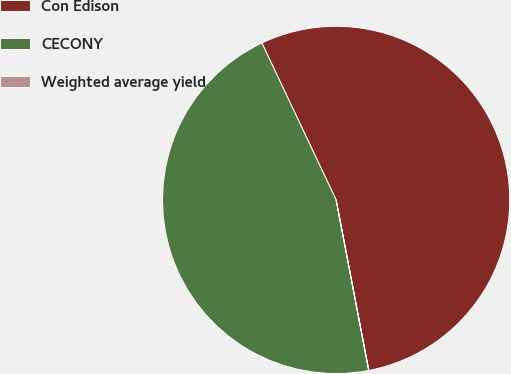Convert chart. <chart><loc_0><loc_0><loc_500><loc_500><pie_chart><fcel>Con Edison<fcel>CECONY<fcel>Weighted average yield<nl><fcel>54.02%<fcel>45.97%<fcel>0.01%<nl></chart> 